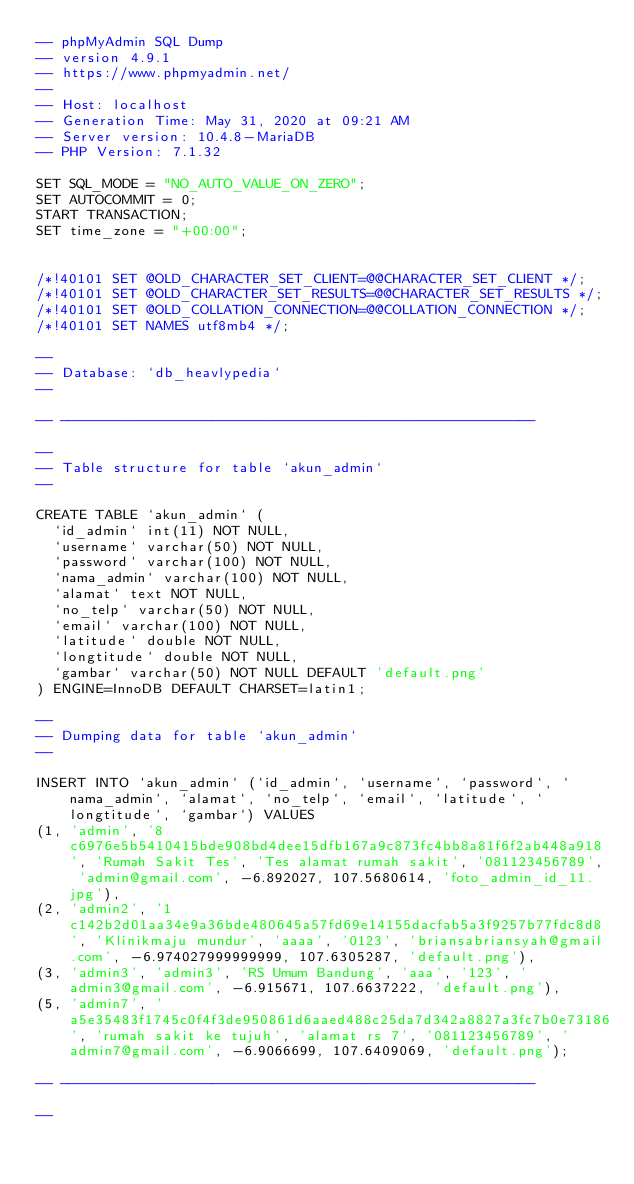Convert code to text. <code><loc_0><loc_0><loc_500><loc_500><_SQL_>-- phpMyAdmin SQL Dump
-- version 4.9.1
-- https://www.phpmyadmin.net/
--
-- Host: localhost
-- Generation Time: May 31, 2020 at 09:21 AM
-- Server version: 10.4.8-MariaDB
-- PHP Version: 7.1.32

SET SQL_MODE = "NO_AUTO_VALUE_ON_ZERO";
SET AUTOCOMMIT = 0;
START TRANSACTION;
SET time_zone = "+00:00";


/*!40101 SET @OLD_CHARACTER_SET_CLIENT=@@CHARACTER_SET_CLIENT */;
/*!40101 SET @OLD_CHARACTER_SET_RESULTS=@@CHARACTER_SET_RESULTS */;
/*!40101 SET @OLD_COLLATION_CONNECTION=@@COLLATION_CONNECTION */;
/*!40101 SET NAMES utf8mb4 */;

--
-- Database: `db_heavlypedia`
--

-- --------------------------------------------------------

--
-- Table structure for table `akun_admin`
--

CREATE TABLE `akun_admin` (
  `id_admin` int(11) NOT NULL,
  `username` varchar(50) NOT NULL,
  `password` varchar(100) NOT NULL,
  `nama_admin` varchar(100) NOT NULL,
  `alamat` text NOT NULL,
  `no_telp` varchar(50) NOT NULL,
  `email` varchar(100) NOT NULL,
  `latitude` double NOT NULL,
  `longtitude` double NOT NULL,
  `gambar` varchar(50) NOT NULL DEFAULT 'default.png'
) ENGINE=InnoDB DEFAULT CHARSET=latin1;

--
-- Dumping data for table `akun_admin`
--

INSERT INTO `akun_admin` (`id_admin`, `username`, `password`, `nama_admin`, `alamat`, `no_telp`, `email`, `latitude`, `longtitude`, `gambar`) VALUES
(1, 'admin', '8c6976e5b5410415bde908bd4dee15dfb167a9c873fc4bb8a81f6f2ab448a918', 'Rumah Sakit Tes', 'Tes alamat rumah sakit', '081123456789', 'admin@gmail.com', -6.892027, 107.5680614, 'foto_admin_id_11.jpg'),
(2, 'admin2', '1c142b2d01aa34e9a36bde480645a57fd69e14155dacfab5a3f9257b77fdc8d8', 'Klinikmaju mundur', 'aaaa', '0123', 'briansabriansyah@gmail.com', -6.974027999999999, 107.6305287, 'default.png'),
(3, 'admin3', 'admin3', 'RS Umum Bandung', 'aaa', '123', 'admin3@gmail.com', -6.915671, 107.6637222, 'default.png'),
(5, 'admin7', 'a5e35483f1745c0f4f3de950861d6aaed488c25da7d342a8827a3fc7b0e73186', 'rumah sakit ke tujuh', 'alamat rs 7', '081123456789', 'admin7@gmail.com', -6.9066699, 107.6409069, 'default.png');

-- --------------------------------------------------------

--</code> 